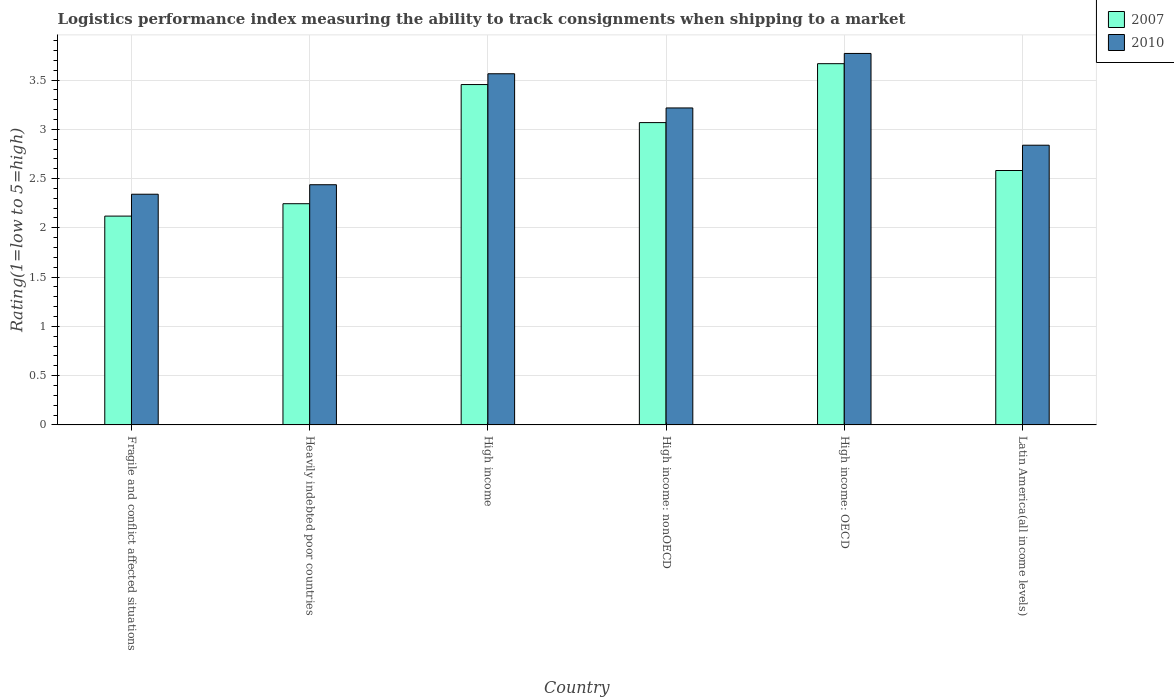How many different coloured bars are there?
Offer a very short reply. 2. How many groups of bars are there?
Your answer should be very brief. 6. Are the number of bars on each tick of the X-axis equal?
Offer a very short reply. Yes. How many bars are there on the 6th tick from the right?
Your response must be concise. 2. What is the label of the 1st group of bars from the left?
Your response must be concise. Fragile and conflict affected situations. What is the Logistic performance index in 2010 in High income?
Your answer should be compact. 3.56. Across all countries, what is the maximum Logistic performance index in 2010?
Offer a very short reply. 3.77. Across all countries, what is the minimum Logistic performance index in 2010?
Provide a short and direct response. 2.34. In which country was the Logistic performance index in 2007 maximum?
Provide a succinct answer. High income: OECD. In which country was the Logistic performance index in 2007 minimum?
Keep it short and to the point. Fragile and conflict affected situations. What is the total Logistic performance index in 2010 in the graph?
Your response must be concise. 18.17. What is the difference between the Logistic performance index in 2010 in Heavily indebted poor countries and that in High income?
Your answer should be compact. -1.13. What is the difference between the Logistic performance index in 2010 in Fragile and conflict affected situations and the Logistic performance index in 2007 in Heavily indebted poor countries?
Your answer should be compact. 0.1. What is the average Logistic performance index in 2010 per country?
Make the answer very short. 3.03. What is the difference between the Logistic performance index of/in 2010 and Logistic performance index of/in 2007 in High income: OECD?
Keep it short and to the point. 0.1. What is the ratio of the Logistic performance index in 2010 in Fragile and conflict affected situations to that in Heavily indebted poor countries?
Provide a short and direct response. 0.96. Is the difference between the Logistic performance index in 2010 in High income: nonOECD and Latin America(all income levels) greater than the difference between the Logistic performance index in 2007 in High income: nonOECD and Latin America(all income levels)?
Offer a very short reply. No. What is the difference between the highest and the second highest Logistic performance index in 2010?
Keep it short and to the point. -0.21. What is the difference between the highest and the lowest Logistic performance index in 2007?
Offer a very short reply. 1.55. In how many countries, is the Logistic performance index in 2007 greater than the average Logistic performance index in 2007 taken over all countries?
Your answer should be very brief. 3. What does the 1st bar from the left in Latin America(all income levels) represents?
Offer a terse response. 2007. What does the 2nd bar from the right in High income: nonOECD represents?
Ensure brevity in your answer.  2007. How many countries are there in the graph?
Offer a very short reply. 6. Are the values on the major ticks of Y-axis written in scientific E-notation?
Your answer should be compact. No. Where does the legend appear in the graph?
Give a very brief answer. Top right. What is the title of the graph?
Provide a short and direct response. Logistics performance index measuring the ability to track consignments when shipping to a market. Does "1998" appear as one of the legend labels in the graph?
Ensure brevity in your answer.  No. What is the label or title of the Y-axis?
Your answer should be compact. Rating(1=low to 5=high). What is the Rating(1=low to 5=high) of 2007 in Fragile and conflict affected situations?
Your response must be concise. 2.12. What is the Rating(1=low to 5=high) of 2010 in Fragile and conflict affected situations?
Your answer should be compact. 2.34. What is the Rating(1=low to 5=high) in 2007 in Heavily indebted poor countries?
Provide a short and direct response. 2.25. What is the Rating(1=low to 5=high) in 2010 in Heavily indebted poor countries?
Provide a succinct answer. 2.44. What is the Rating(1=low to 5=high) of 2007 in High income?
Ensure brevity in your answer.  3.45. What is the Rating(1=low to 5=high) of 2010 in High income?
Your answer should be compact. 3.56. What is the Rating(1=low to 5=high) of 2007 in High income: nonOECD?
Make the answer very short. 3.07. What is the Rating(1=low to 5=high) of 2010 in High income: nonOECD?
Provide a short and direct response. 3.22. What is the Rating(1=low to 5=high) of 2007 in High income: OECD?
Provide a succinct answer. 3.67. What is the Rating(1=low to 5=high) of 2010 in High income: OECD?
Provide a succinct answer. 3.77. What is the Rating(1=low to 5=high) of 2007 in Latin America(all income levels)?
Your answer should be compact. 2.58. What is the Rating(1=low to 5=high) in 2010 in Latin America(all income levels)?
Your response must be concise. 2.84. Across all countries, what is the maximum Rating(1=low to 5=high) of 2007?
Offer a terse response. 3.67. Across all countries, what is the maximum Rating(1=low to 5=high) of 2010?
Your response must be concise. 3.77. Across all countries, what is the minimum Rating(1=low to 5=high) of 2007?
Make the answer very short. 2.12. Across all countries, what is the minimum Rating(1=low to 5=high) of 2010?
Ensure brevity in your answer.  2.34. What is the total Rating(1=low to 5=high) of 2007 in the graph?
Keep it short and to the point. 17.13. What is the total Rating(1=low to 5=high) in 2010 in the graph?
Keep it short and to the point. 18.17. What is the difference between the Rating(1=low to 5=high) of 2007 in Fragile and conflict affected situations and that in Heavily indebted poor countries?
Provide a short and direct response. -0.13. What is the difference between the Rating(1=low to 5=high) in 2010 in Fragile and conflict affected situations and that in Heavily indebted poor countries?
Offer a terse response. -0.1. What is the difference between the Rating(1=low to 5=high) in 2007 in Fragile and conflict affected situations and that in High income?
Ensure brevity in your answer.  -1.34. What is the difference between the Rating(1=low to 5=high) in 2010 in Fragile and conflict affected situations and that in High income?
Provide a succinct answer. -1.22. What is the difference between the Rating(1=low to 5=high) in 2007 in Fragile and conflict affected situations and that in High income: nonOECD?
Make the answer very short. -0.95. What is the difference between the Rating(1=low to 5=high) in 2010 in Fragile and conflict affected situations and that in High income: nonOECD?
Provide a short and direct response. -0.88. What is the difference between the Rating(1=low to 5=high) in 2007 in Fragile and conflict affected situations and that in High income: OECD?
Your response must be concise. -1.55. What is the difference between the Rating(1=low to 5=high) of 2010 in Fragile and conflict affected situations and that in High income: OECD?
Your response must be concise. -1.43. What is the difference between the Rating(1=low to 5=high) of 2007 in Fragile and conflict affected situations and that in Latin America(all income levels)?
Keep it short and to the point. -0.46. What is the difference between the Rating(1=low to 5=high) of 2010 in Fragile and conflict affected situations and that in Latin America(all income levels)?
Offer a very short reply. -0.5. What is the difference between the Rating(1=low to 5=high) in 2007 in Heavily indebted poor countries and that in High income?
Your answer should be very brief. -1.21. What is the difference between the Rating(1=low to 5=high) of 2010 in Heavily indebted poor countries and that in High income?
Give a very brief answer. -1.13. What is the difference between the Rating(1=low to 5=high) of 2007 in Heavily indebted poor countries and that in High income: nonOECD?
Your response must be concise. -0.82. What is the difference between the Rating(1=low to 5=high) of 2010 in Heavily indebted poor countries and that in High income: nonOECD?
Your response must be concise. -0.78. What is the difference between the Rating(1=low to 5=high) of 2007 in Heavily indebted poor countries and that in High income: OECD?
Ensure brevity in your answer.  -1.42. What is the difference between the Rating(1=low to 5=high) in 2010 in Heavily indebted poor countries and that in High income: OECD?
Ensure brevity in your answer.  -1.33. What is the difference between the Rating(1=low to 5=high) of 2007 in Heavily indebted poor countries and that in Latin America(all income levels)?
Ensure brevity in your answer.  -0.34. What is the difference between the Rating(1=low to 5=high) of 2010 in Heavily indebted poor countries and that in Latin America(all income levels)?
Your answer should be very brief. -0.4. What is the difference between the Rating(1=low to 5=high) of 2007 in High income and that in High income: nonOECD?
Offer a terse response. 0.39. What is the difference between the Rating(1=low to 5=high) in 2010 in High income and that in High income: nonOECD?
Provide a succinct answer. 0.35. What is the difference between the Rating(1=low to 5=high) in 2007 in High income and that in High income: OECD?
Provide a short and direct response. -0.21. What is the difference between the Rating(1=low to 5=high) of 2010 in High income and that in High income: OECD?
Your answer should be very brief. -0.21. What is the difference between the Rating(1=low to 5=high) of 2007 in High income and that in Latin America(all income levels)?
Your answer should be compact. 0.87. What is the difference between the Rating(1=low to 5=high) of 2010 in High income and that in Latin America(all income levels)?
Your response must be concise. 0.73. What is the difference between the Rating(1=low to 5=high) in 2007 in High income: nonOECD and that in High income: OECD?
Keep it short and to the point. -0.6. What is the difference between the Rating(1=low to 5=high) of 2010 in High income: nonOECD and that in High income: OECD?
Your answer should be very brief. -0.55. What is the difference between the Rating(1=low to 5=high) in 2007 in High income: nonOECD and that in Latin America(all income levels)?
Provide a short and direct response. 0.49. What is the difference between the Rating(1=low to 5=high) in 2010 in High income: nonOECD and that in Latin America(all income levels)?
Give a very brief answer. 0.38. What is the difference between the Rating(1=low to 5=high) of 2007 in High income: OECD and that in Latin America(all income levels)?
Keep it short and to the point. 1.08. What is the difference between the Rating(1=low to 5=high) in 2010 in High income: OECD and that in Latin America(all income levels)?
Your answer should be compact. 0.93. What is the difference between the Rating(1=low to 5=high) in 2007 in Fragile and conflict affected situations and the Rating(1=low to 5=high) in 2010 in Heavily indebted poor countries?
Keep it short and to the point. -0.32. What is the difference between the Rating(1=low to 5=high) of 2007 in Fragile and conflict affected situations and the Rating(1=low to 5=high) of 2010 in High income?
Provide a short and direct response. -1.44. What is the difference between the Rating(1=low to 5=high) of 2007 in Fragile and conflict affected situations and the Rating(1=low to 5=high) of 2010 in High income: nonOECD?
Make the answer very short. -1.1. What is the difference between the Rating(1=low to 5=high) in 2007 in Fragile and conflict affected situations and the Rating(1=low to 5=high) in 2010 in High income: OECD?
Provide a short and direct response. -1.65. What is the difference between the Rating(1=low to 5=high) of 2007 in Fragile and conflict affected situations and the Rating(1=low to 5=high) of 2010 in Latin America(all income levels)?
Offer a terse response. -0.72. What is the difference between the Rating(1=low to 5=high) of 2007 in Heavily indebted poor countries and the Rating(1=low to 5=high) of 2010 in High income?
Keep it short and to the point. -1.32. What is the difference between the Rating(1=low to 5=high) in 2007 in Heavily indebted poor countries and the Rating(1=low to 5=high) in 2010 in High income: nonOECD?
Give a very brief answer. -0.97. What is the difference between the Rating(1=low to 5=high) of 2007 in Heavily indebted poor countries and the Rating(1=low to 5=high) of 2010 in High income: OECD?
Give a very brief answer. -1.52. What is the difference between the Rating(1=low to 5=high) of 2007 in Heavily indebted poor countries and the Rating(1=low to 5=high) of 2010 in Latin America(all income levels)?
Offer a very short reply. -0.59. What is the difference between the Rating(1=low to 5=high) of 2007 in High income and the Rating(1=low to 5=high) of 2010 in High income: nonOECD?
Offer a very short reply. 0.24. What is the difference between the Rating(1=low to 5=high) of 2007 in High income and the Rating(1=low to 5=high) of 2010 in High income: OECD?
Provide a succinct answer. -0.32. What is the difference between the Rating(1=low to 5=high) in 2007 in High income and the Rating(1=low to 5=high) in 2010 in Latin America(all income levels)?
Your answer should be compact. 0.62. What is the difference between the Rating(1=low to 5=high) in 2007 in High income: nonOECD and the Rating(1=low to 5=high) in 2010 in High income: OECD?
Your answer should be very brief. -0.7. What is the difference between the Rating(1=low to 5=high) in 2007 in High income: nonOECD and the Rating(1=low to 5=high) in 2010 in Latin America(all income levels)?
Your response must be concise. 0.23. What is the difference between the Rating(1=low to 5=high) in 2007 in High income: OECD and the Rating(1=low to 5=high) in 2010 in Latin America(all income levels)?
Offer a terse response. 0.83. What is the average Rating(1=low to 5=high) of 2007 per country?
Offer a very short reply. 2.86. What is the average Rating(1=low to 5=high) in 2010 per country?
Keep it short and to the point. 3.03. What is the difference between the Rating(1=low to 5=high) in 2007 and Rating(1=low to 5=high) in 2010 in Fragile and conflict affected situations?
Your answer should be very brief. -0.22. What is the difference between the Rating(1=low to 5=high) in 2007 and Rating(1=low to 5=high) in 2010 in Heavily indebted poor countries?
Ensure brevity in your answer.  -0.19. What is the difference between the Rating(1=low to 5=high) of 2007 and Rating(1=low to 5=high) of 2010 in High income?
Ensure brevity in your answer.  -0.11. What is the difference between the Rating(1=low to 5=high) in 2007 and Rating(1=low to 5=high) in 2010 in High income: nonOECD?
Ensure brevity in your answer.  -0.15. What is the difference between the Rating(1=low to 5=high) in 2007 and Rating(1=low to 5=high) in 2010 in High income: OECD?
Provide a short and direct response. -0.1. What is the difference between the Rating(1=low to 5=high) of 2007 and Rating(1=low to 5=high) of 2010 in Latin America(all income levels)?
Your answer should be very brief. -0.26. What is the ratio of the Rating(1=low to 5=high) of 2007 in Fragile and conflict affected situations to that in Heavily indebted poor countries?
Your answer should be compact. 0.94. What is the ratio of the Rating(1=low to 5=high) in 2010 in Fragile and conflict affected situations to that in Heavily indebted poor countries?
Your response must be concise. 0.96. What is the ratio of the Rating(1=low to 5=high) in 2007 in Fragile and conflict affected situations to that in High income?
Your answer should be compact. 0.61. What is the ratio of the Rating(1=low to 5=high) of 2010 in Fragile and conflict affected situations to that in High income?
Offer a very short reply. 0.66. What is the ratio of the Rating(1=low to 5=high) of 2007 in Fragile and conflict affected situations to that in High income: nonOECD?
Keep it short and to the point. 0.69. What is the ratio of the Rating(1=low to 5=high) in 2010 in Fragile and conflict affected situations to that in High income: nonOECD?
Provide a short and direct response. 0.73. What is the ratio of the Rating(1=low to 5=high) in 2007 in Fragile and conflict affected situations to that in High income: OECD?
Your answer should be very brief. 0.58. What is the ratio of the Rating(1=low to 5=high) of 2010 in Fragile and conflict affected situations to that in High income: OECD?
Give a very brief answer. 0.62. What is the ratio of the Rating(1=low to 5=high) of 2007 in Fragile and conflict affected situations to that in Latin America(all income levels)?
Ensure brevity in your answer.  0.82. What is the ratio of the Rating(1=low to 5=high) of 2010 in Fragile and conflict affected situations to that in Latin America(all income levels)?
Provide a short and direct response. 0.82. What is the ratio of the Rating(1=low to 5=high) of 2007 in Heavily indebted poor countries to that in High income?
Your answer should be very brief. 0.65. What is the ratio of the Rating(1=low to 5=high) in 2010 in Heavily indebted poor countries to that in High income?
Your answer should be very brief. 0.68. What is the ratio of the Rating(1=low to 5=high) in 2007 in Heavily indebted poor countries to that in High income: nonOECD?
Your answer should be compact. 0.73. What is the ratio of the Rating(1=low to 5=high) in 2010 in Heavily indebted poor countries to that in High income: nonOECD?
Ensure brevity in your answer.  0.76. What is the ratio of the Rating(1=low to 5=high) of 2007 in Heavily indebted poor countries to that in High income: OECD?
Give a very brief answer. 0.61. What is the ratio of the Rating(1=low to 5=high) of 2010 in Heavily indebted poor countries to that in High income: OECD?
Your answer should be very brief. 0.65. What is the ratio of the Rating(1=low to 5=high) in 2007 in Heavily indebted poor countries to that in Latin America(all income levels)?
Give a very brief answer. 0.87. What is the ratio of the Rating(1=low to 5=high) of 2010 in Heavily indebted poor countries to that in Latin America(all income levels)?
Provide a short and direct response. 0.86. What is the ratio of the Rating(1=low to 5=high) of 2007 in High income to that in High income: nonOECD?
Offer a terse response. 1.13. What is the ratio of the Rating(1=low to 5=high) in 2010 in High income to that in High income: nonOECD?
Make the answer very short. 1.11. What is the ratio of the Rating(1=low to 5=high) in 2007 in High income to that in High income: OECD?
Ensure brevity in your answer.  0.94. What is the ratio of the Rating(1=low to 5=high) in 2010 in High income to that in High income: OECD?
Offer a terse response. 0.95. What is the ratio of the Rating(1=low to 5=high) in 2007 in High income to that in Latin America(all income levels)?
Ensure brevity in your answer.  1.34. What is the ratio of the Rating(1=low to 5=high) of 2010 in High income to that in Latin America(all income levels)?
Keep it short and to the point. 1.26. What is the ratio of the Rating(1=low to 5=high) of 2007 in High income: nonOECD to that in High income: OECD?
Make the answer very short. 0.84. What is the ratio of the Rating(1=low to 5=high) in 2010 in High income: nonOECD to that in High income: OECD?
Your answer should be compact. 0.85. What is the ratio of the Rating(1=low to 5=high) in 2007 in High income: nonOECD to that in Latin America(all income levels)?
Provide a succinct answer. 1.19. What is the ratio of the Rating(1=low to 5=high) of 2010 in High income: nonOECD to that in Latin America(all income levels)?
Make the answer very short. 1.13. What is the ratio of the Rating(1=low to 5=high) of 2007 in High income: OECD to that in Latin America(all income levels)?
Your answer should be compact. 1.42. What is the ratio of the Rating(1=low to 5=high) in 2010 in High income: OECD to that in Latin America(all income levels)?
Your answer should be very brief. 1.33. What is the difference between the highest and the second highest Rating(1=low to 5=high) of 2007?
Offer a terse response. 0.21. What is the difference between the highest and the second highest Rating(1=low to 5=high) in 2010?
Your answer should be very brief. 0.21. What is the difference between the highest and the lowest Rating(1=low to 5=high) of 2007?
Your response must be concise. 1.55. What is the difference between the highest and the lowest Rating(1=low to 5=high) in 2010?
Offer a very short reply. 1.43. 